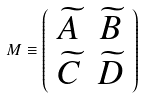Convert formula to latex. <formula><loc_0><loc_0><loc_500><loc_500>M \equiv \left ( \begin{array} { c c } \widetilde { A } & \widetilde { B } \\ \widetilde { C } & \widetilde { D } \end{array} \right ) \text { \ }</formula> 